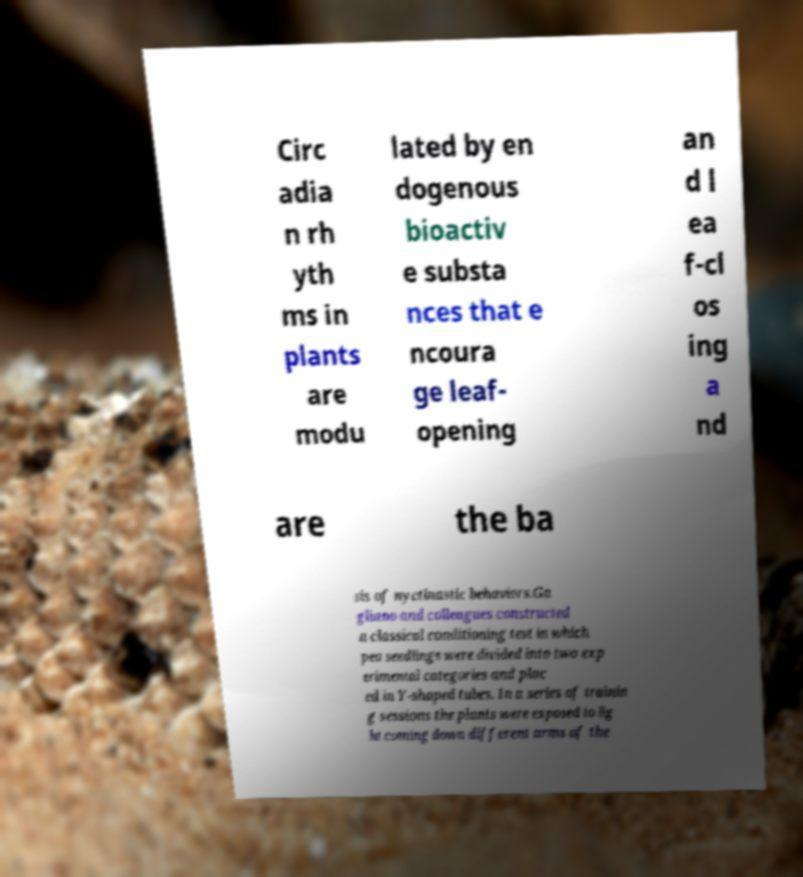Please identify and transcribe the text found in this image. Circ adia n rh yth ms in plants are modu lated by en dogenous bioactiv e substa nces that e ncoura ge leaf- opening an d l ea f-cl os ing a nd are the ba sis of nyctinastic behaviors.Ga gliano and colleagues constructed a classical conditioning test in which pea seedlings were divided into two exp erimental categories and plac ed in Y-shaped tubes. In a series of trainin g sessions the plants were exposed to lig ht coming down different arms of the 